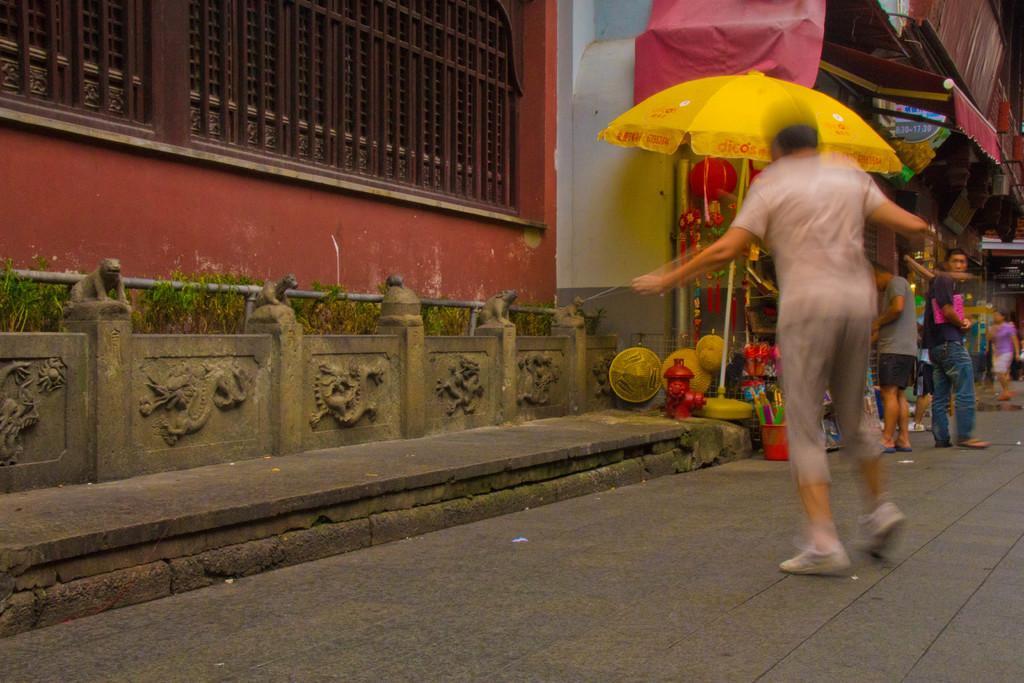Can you describe this image briefly? In this picture we can see group of people and few buildings, in front of them we can see a water hydrant, an umbrella and other things, and also we can see metal rods and few plants. 